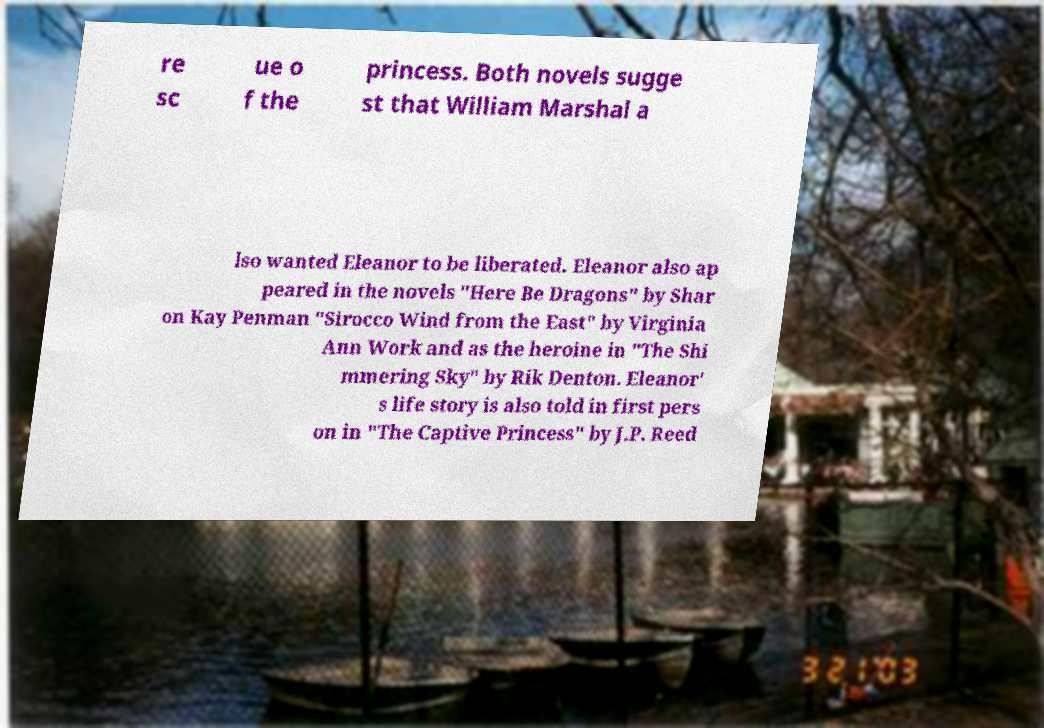I need the written content from this picture converted into text. Can you do that? re sc ue o f the princess. Both novels sugge st that William Marshal a lso wanted Eleanor to be liberated. Eleanor also ap peared in the novels "Here Be Dragons" by Shar on Kay Penman "Sirocco Wind from the East" by Virginia Ann Work and as the heroine in "The Shi mmering Sky" by Rik Denton. Eleanor' s life story is also told in first pers on in "The Captive Princess" by J.P. Reed 